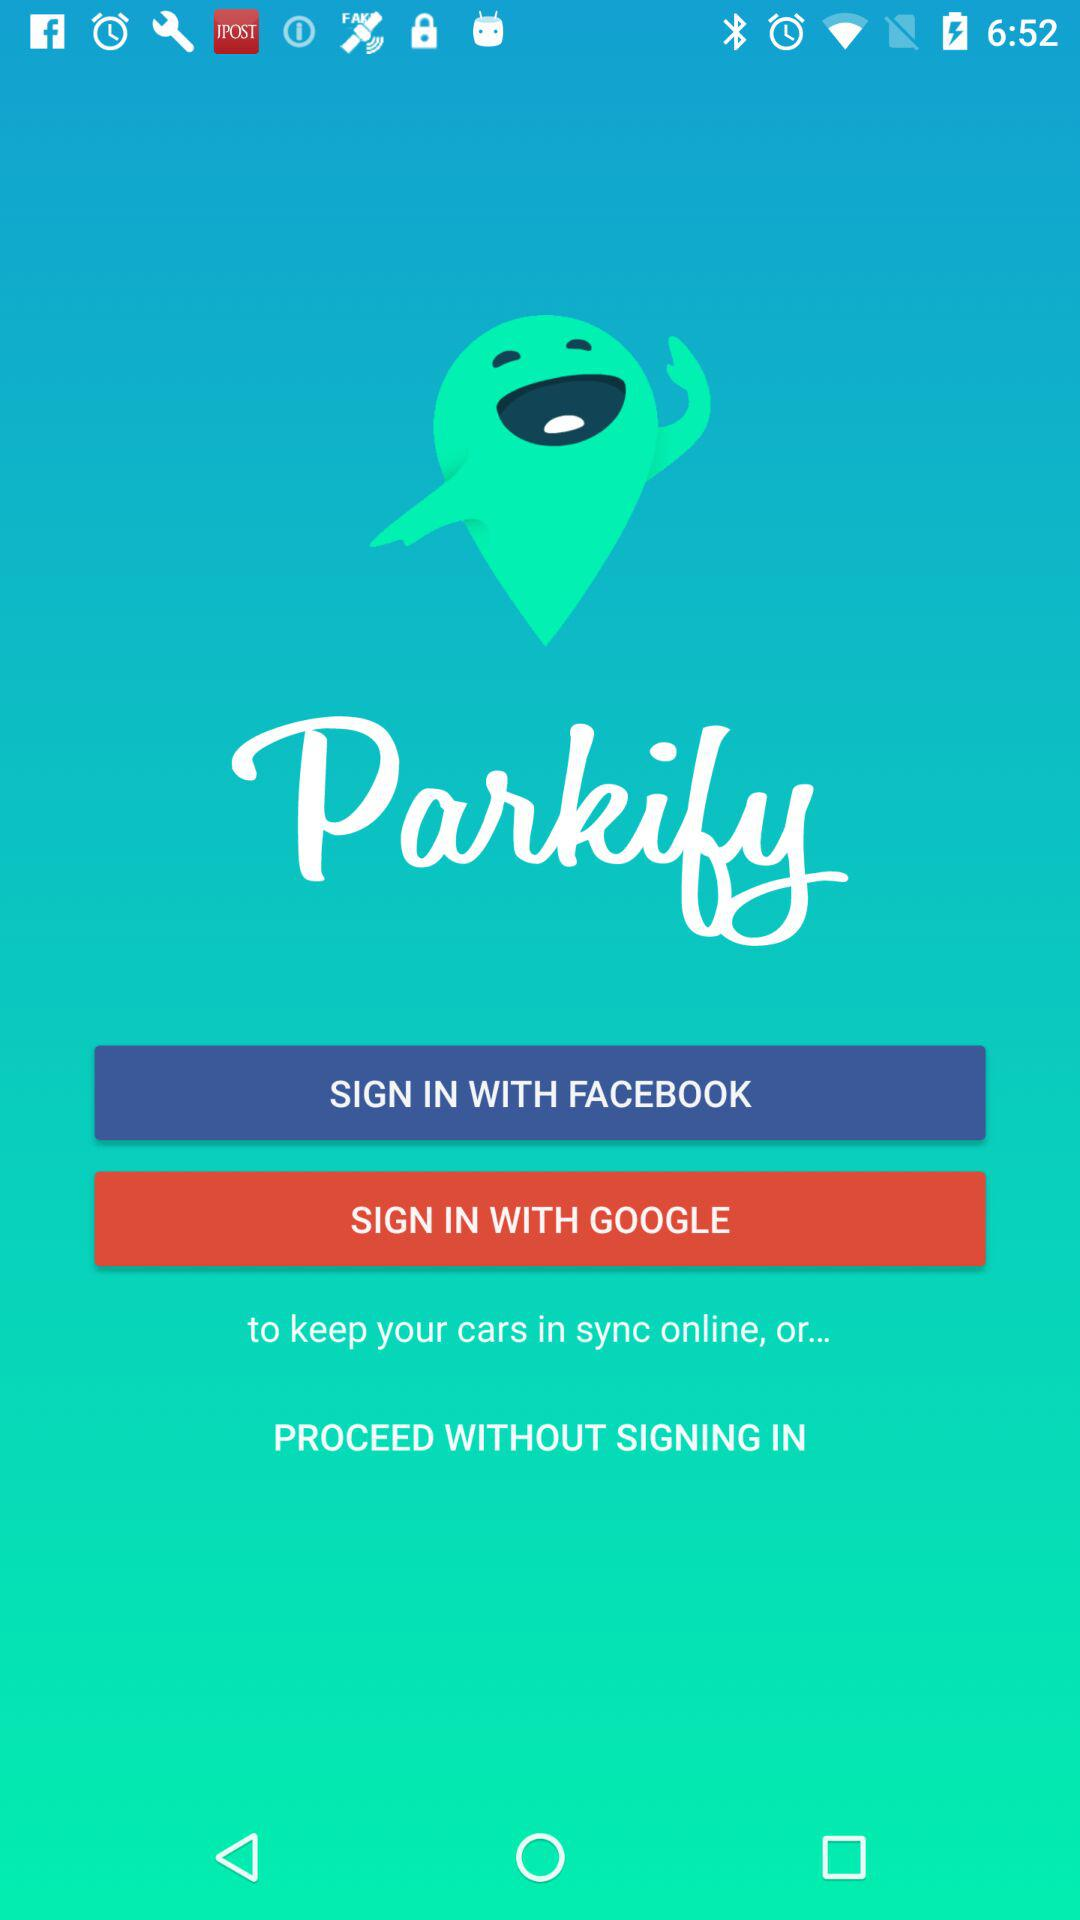How many sign in options are there?
Answer the question using a single word or phrase. 2 